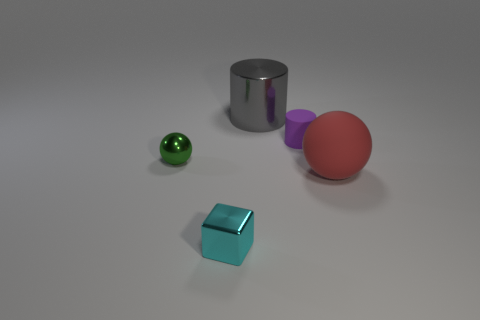Subtract all red cylinders. How many green spheres are left? 1 Subtract 2 balls. How many balls are left? 0 Subtract all cyan cylinders. Subtract all yellow cubes. How many cylinders are left? 2 Subtract all purple cylinders. Subtract all red matte things. How many objects are left? 3 Add 1 purple rubber cylinders. How many purple rubber cylinders are left? 2 Add 5 big blue matte things. How many big blue matte things exist? 5 Add 2 tiny gray matte objects. How many objects exist? 7 Subtract 0 brown cubes. How many objects are left? 5 Subtract all blocks. How many objects are left? 4 